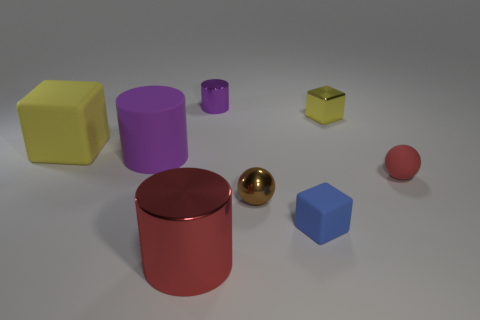What material is the tiny ball that is the same color as the large shiny object?
Your answer should be compact. Rubber. The red thing that is the same shape as the purple metallic object is what size?
Make the answer very short. Large. Does the red cylinder have the same size as the purple metallic cylinder?
Give a very brief answer. No. Is the number of tiny cyan cylinders greater than the number of tiny things?
Provide a short and direct response. No. How many other things are the same color as the metal block?
Your answer should be compact. 1. How many objects are small cylinders or big red metallic blocks?
Offer a terse response. 1. Do the purple object that is behind the large rubber cylinder and the tiny red thing have the same shape?
Offer a very short reply. No. There is a metal cylinder that is on the right side of the big object that is in front of the brown metal sphere; what color is it?
Your answer should be very brief. Purple. Is the number of yellow matte cubes less than the number of green objects?
Provide a short and direct response. No. Are there any tiny gray cubes that have the same material as the large yellow block?
Provide a succinct answer. No. 